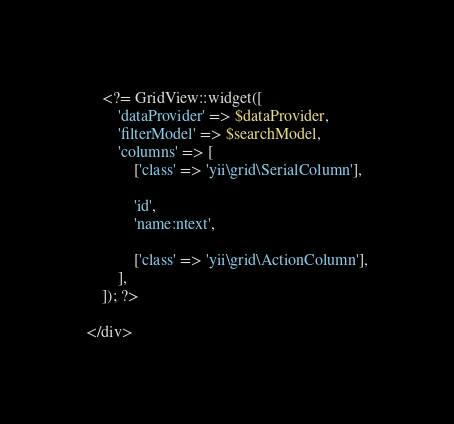Convert code to text. <code><loc_0><loc_0><loc_500><loc_500><_PHP_>    <?= GridView::widget([
        'dataProvider' => $dataProvider,
        'filterModel' => $searchModel,
        'columns' => [
            ['class' => 'yii\grid\SerialColumn'],

            'id',
            'name:ntext',

            ['class' => 'yii\grid\ActionColumn'],
        ],
    ]); ?>

</div>
</code> 